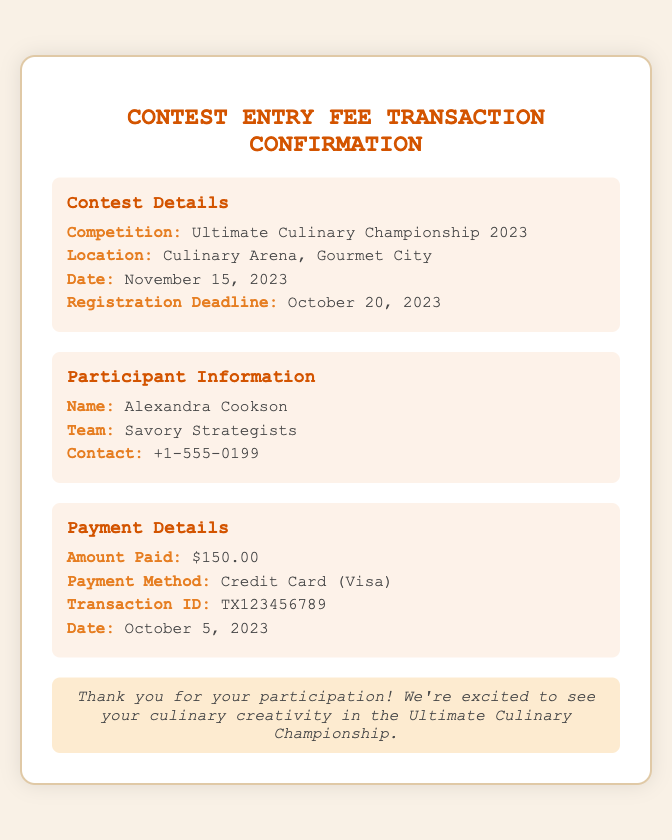What is the competition name? The competition name is clearly stated in the contest details section of the document.
Answer: Ultimate Culinary Championship 2023 What is the amount paid for the entry fee? The payment details section specifies the exact amount that was paid.
Answer: $150.00 When is the registration deadline? The registration deadline is indicated in the contest details, showing the last date to register for the contest.
Answer: October 20, 2023 Who is the participant's team? This information can be found in the participant information section, mentioning the name of the team.
Answer: Savory Strategists What is the payment method used? The payment details clearly specify the method of payment used in the transaction.
Answer: Credit Card (Visa) Where is the competition taking place? The location is provided in the contest details section, indicating where the event will be hosted.
Answer: Culinary Arena, Gourmet City What is the transaction ID? The transaction ID is mentioned in the payment details, serving as a unique identifier for the transaction.
Answer: TX123456789 What date was the payment made? The date of payment is listed in the payment details section of the document.
Answer: October 5, 2023 